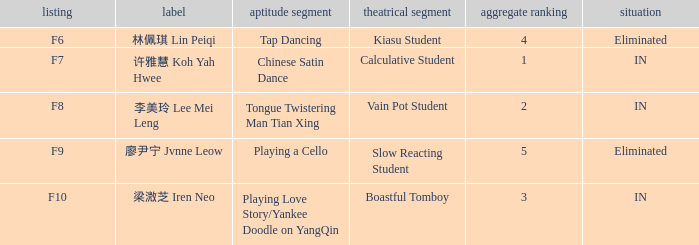For the event with index f7, what is the status? IN. 